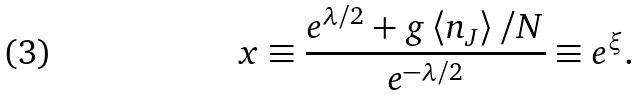Convert formula to latex. <formula><loc_0><loc_0><loc_500><loc_500>x \equiv \frac { e ^ { \lambda / 2 } + g \left < n _ { J } \right > / N } { e ^ { - \lambda / 2 } } \equiv e ^ { \xi } .</formula> 